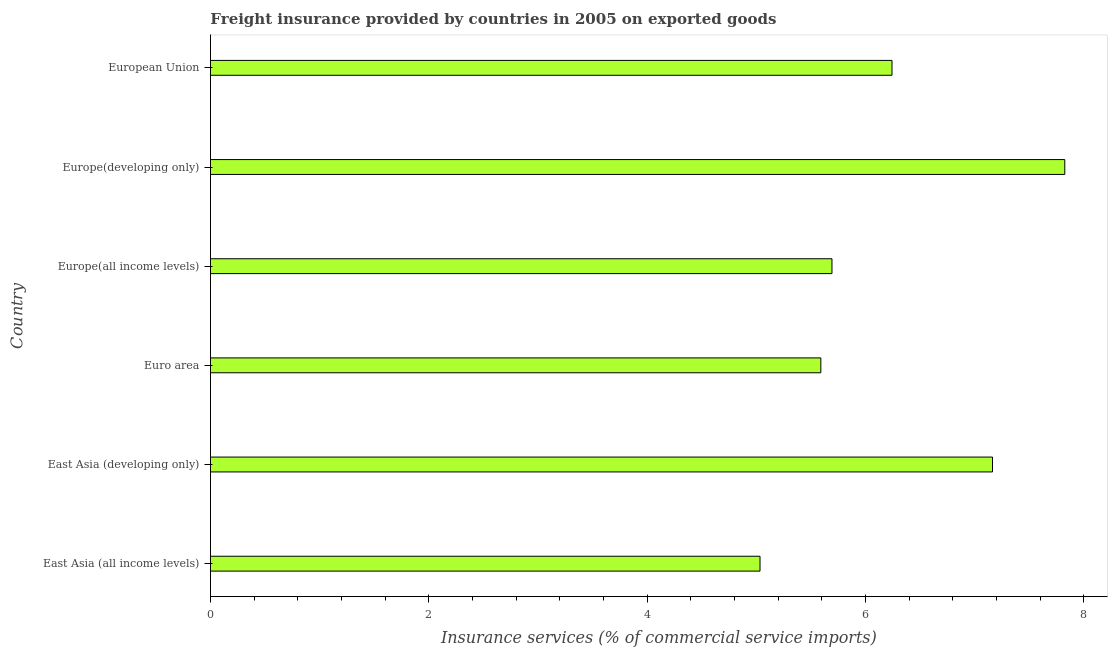Does the graph contain any zero values?
Provide a short and direct response. No. Does the graph contain grids?
Offer a very short reply. No. What is the title of the graph?
Provide a short and direct response. Freight insurance provided by countries in 2005 on exported goods . What is the label or title of the X-axis?
Give a very brief answer. Insurance services (% of commercial service imports). What is the freight insurance in Europe(all income levels)?
Your answer should be very brief. 5.69. Across all countries, what is the maximum freight insurance?
Provide a short and direct response. 7.83. Across all countries, what is the minimum freight insurance?
Your answer should be compact. 5.03. In which country was the freight insurance maximum?
Make the answer very short. Europe(developing only). In which country was the freight insurance minimum?
Provide a succinct answer. East Asia (all income levels). What is the sum of the freight insurance?
Your answer should be very brief. 37.55. What is the difference between the freight insurance in East Asia (developing only) and Europe(developing only)?
Offer a very short reply. -0.66. What is the average freight insurance per country?
Provide a succinct answer. 6.26. What is the median freight insurance?
Keep it short and to the point. 5.97. What is the ratio of the freight insurance in East Asia (all income levels) to that in European Union?
Give a very brief answer. 0.81. Is the difference between the freight insurance in Europe(developing only) and European Union greater than the difference between any two countries?
Provide a short and direct response. No. What is the difference between the highest and the second highest freight insurance?
Your response must be concise. 0.66. What is the difference between the highest and the lowest freight insurance?
Keep it short and to the point. 2.79. In how many countries, is the freight insurance greater than the average freight insurance taken over all countries?
Your answer should be compact. 2. How many countries are there in the graph?
Your response must be concise. 6. Are the values on the major ticks of X-axis written in scientific E-notation?
Offer a very short reply. No. What is the Insurance services (% of commercial service imports) in East Asia (all income levels)?
Keep it short and to the point. 5.03. What is the Insurance services (% of commercial service imports) of East Asia (developing only)?
Your answer should be compact. 7.16. What is the Insurance services (% of commercial service imports) in Euro area?
Your response must be concise. 5.59. What is the Insurance services (% of commercial service imports) in Europe(all income levels)?
Ensure brevity in your answer.  5.69. What is the Insurance services (% of commercial service imports) of Europe(developing only)?
Your answer should be compact. 7.83. What is the Insurance services (% of commercial service imports) of European Union?
Ensure brevity in your answer.  6.24. What is the difference between the Insurance services (% of commercial service imports) in East Asia (all income levels) and East Asia (developing only)?
Make the answer very short. -2.13. What is the difference between the Insurance services (% of commercial service imports) in East Asia (all income levels) and Euro area?
Offer a very short reply. -0.56. What is the difference between the Insurance services (% of commercial service imports) in East Asia (all income levels) and Europe(all income levels)?
Ensure brevity in your answer.  -0.66. What is the difference between the Insurance services (% of commercial service imports) in East Asia (all income levels) and Europe(developing only)?
Your answer should be compact. -2.79. What is the difference between the Insurance services (% of commercial service imports) in East Asia (all income levels) and European Union?
Provide a succinct answer. -1.21. What is the difference between the Insurance services (% of commercial service imports) in East Asia (developing only) and Euro area?
Keep it short and to the point. 1.57. What is the difference between the Insurance services (% of commercial service imports) in East Asia (developing only) and Europe(all income levels)?
Your response must be concise. 1.47. What is the difference between the Insurance services (% of commercial service imports) in East Asia (developing only) and Europe(developing only)?
Provide a succinct answer. -0.66. What is the difference between the Insurance services (% of commercial service imports) in East Asia (developing only) and European Union?
Your answer should be very brief. 0.92. What is the difference between the Insurance services (% of commercial service imports) in Euro area and Europe(all income levels)?
Offer a very short reply. -0.1. What is the difference between the Insurance services (% of commercial service imports) in Euro area and Europe(developing only)?
Keep it short and to the point. -2.23. What is the difference between the Insurance services (% of commercial service imports) in Euro area and European Union?
Your answer should be very brief. -0.65. What is the difference between the Insurance services (% of commercial service imports) in Europe(all income levels) and Europe(developing only)?
Ensure brevity in your answer.  -2.13. What is the difference between the Insurance services (% of commercial service imports) in Europe(all income levels) and European Union?
Make the answer very short. -0.55. What is the difference between the Insurance services (% of commercial service imports) in Europe(developing only) and European Union?
Provide a succinct answer. 1.58. What is the ratio of the Insurance services (% of commercial service imports) in East Asia (all income levels) to that in East Asia (developing only)?
Your answer should be very brief. 0.7. What is the ratio of the Insurance services (% of commercial service imports) in East Asia (all income levels) to that in Euro area?
Your response must be concise. 0.9. What is the ratio of the Insurance services (% of commercial service imports) in East Asia (all income levels) to that in Europe(all income levels)?
Your answer should be compact. 0.88. What is the ratio of the Insurance services (% of commercial service imports) in East Asia (all income levels) to that in Europe(developing only)?
Your answer should be compact. 0.64. What is the ratio of the Insurance services (% of commercial service imports) in East Asia (all income levels) to that in European Union?
Keep it short and to the point. 0.81. What is the ratio of the Insurance services (% of commercial service imports) in East Asia (developing only) to that in Euro area?
Ensure brevity in your answer.  1.28. What is the ratio of the Insurance services (% of commercial service imports) in East Asia (developing only) to that in Europe(all income levels)?
Your answer should be compact. 1.26. What is the ratio of the Insurance services (% of commercial service imports) in East Asia (developing only) to that in Europe(developing only)?
Ensure brevity in your answer.  0.92. What is the ratio of the Insurance services (% of commercial service imports) in East Asia (developing only) to that in European Union?
Provide a succinct answer. 1.15. What is the ratio of the Insurance services (% of commercial service imports) in Euro area to that in Europe(all income levels)?
Offer a very short reply. 0.98. What is the ratio of the Insurance services (% of commercial service imports) in Euro area to that in Europe(developing only)?
Ensure brevity in your answer.  0.71. What is the ratio of the Insurance services (% of commercial service imports) in Euro area to that in European Union?
Your answer should be compact. 0.9. What is the ratio of the Insurance services (% of commercial service imports) in Europe(all income levels) to that in Europe(developing only)?
Offer a terse response. 0.73. What is the ratio of the Insurance services (% of commercial service imports) in Europe(all income levels) to that in European Union?
Your response must be concise. 0.91. What is the ratio of the Insurance services (% of commercial service imports) in Europe(developing only) to that in European Union?
Provide a short and direct response. 1.25. 